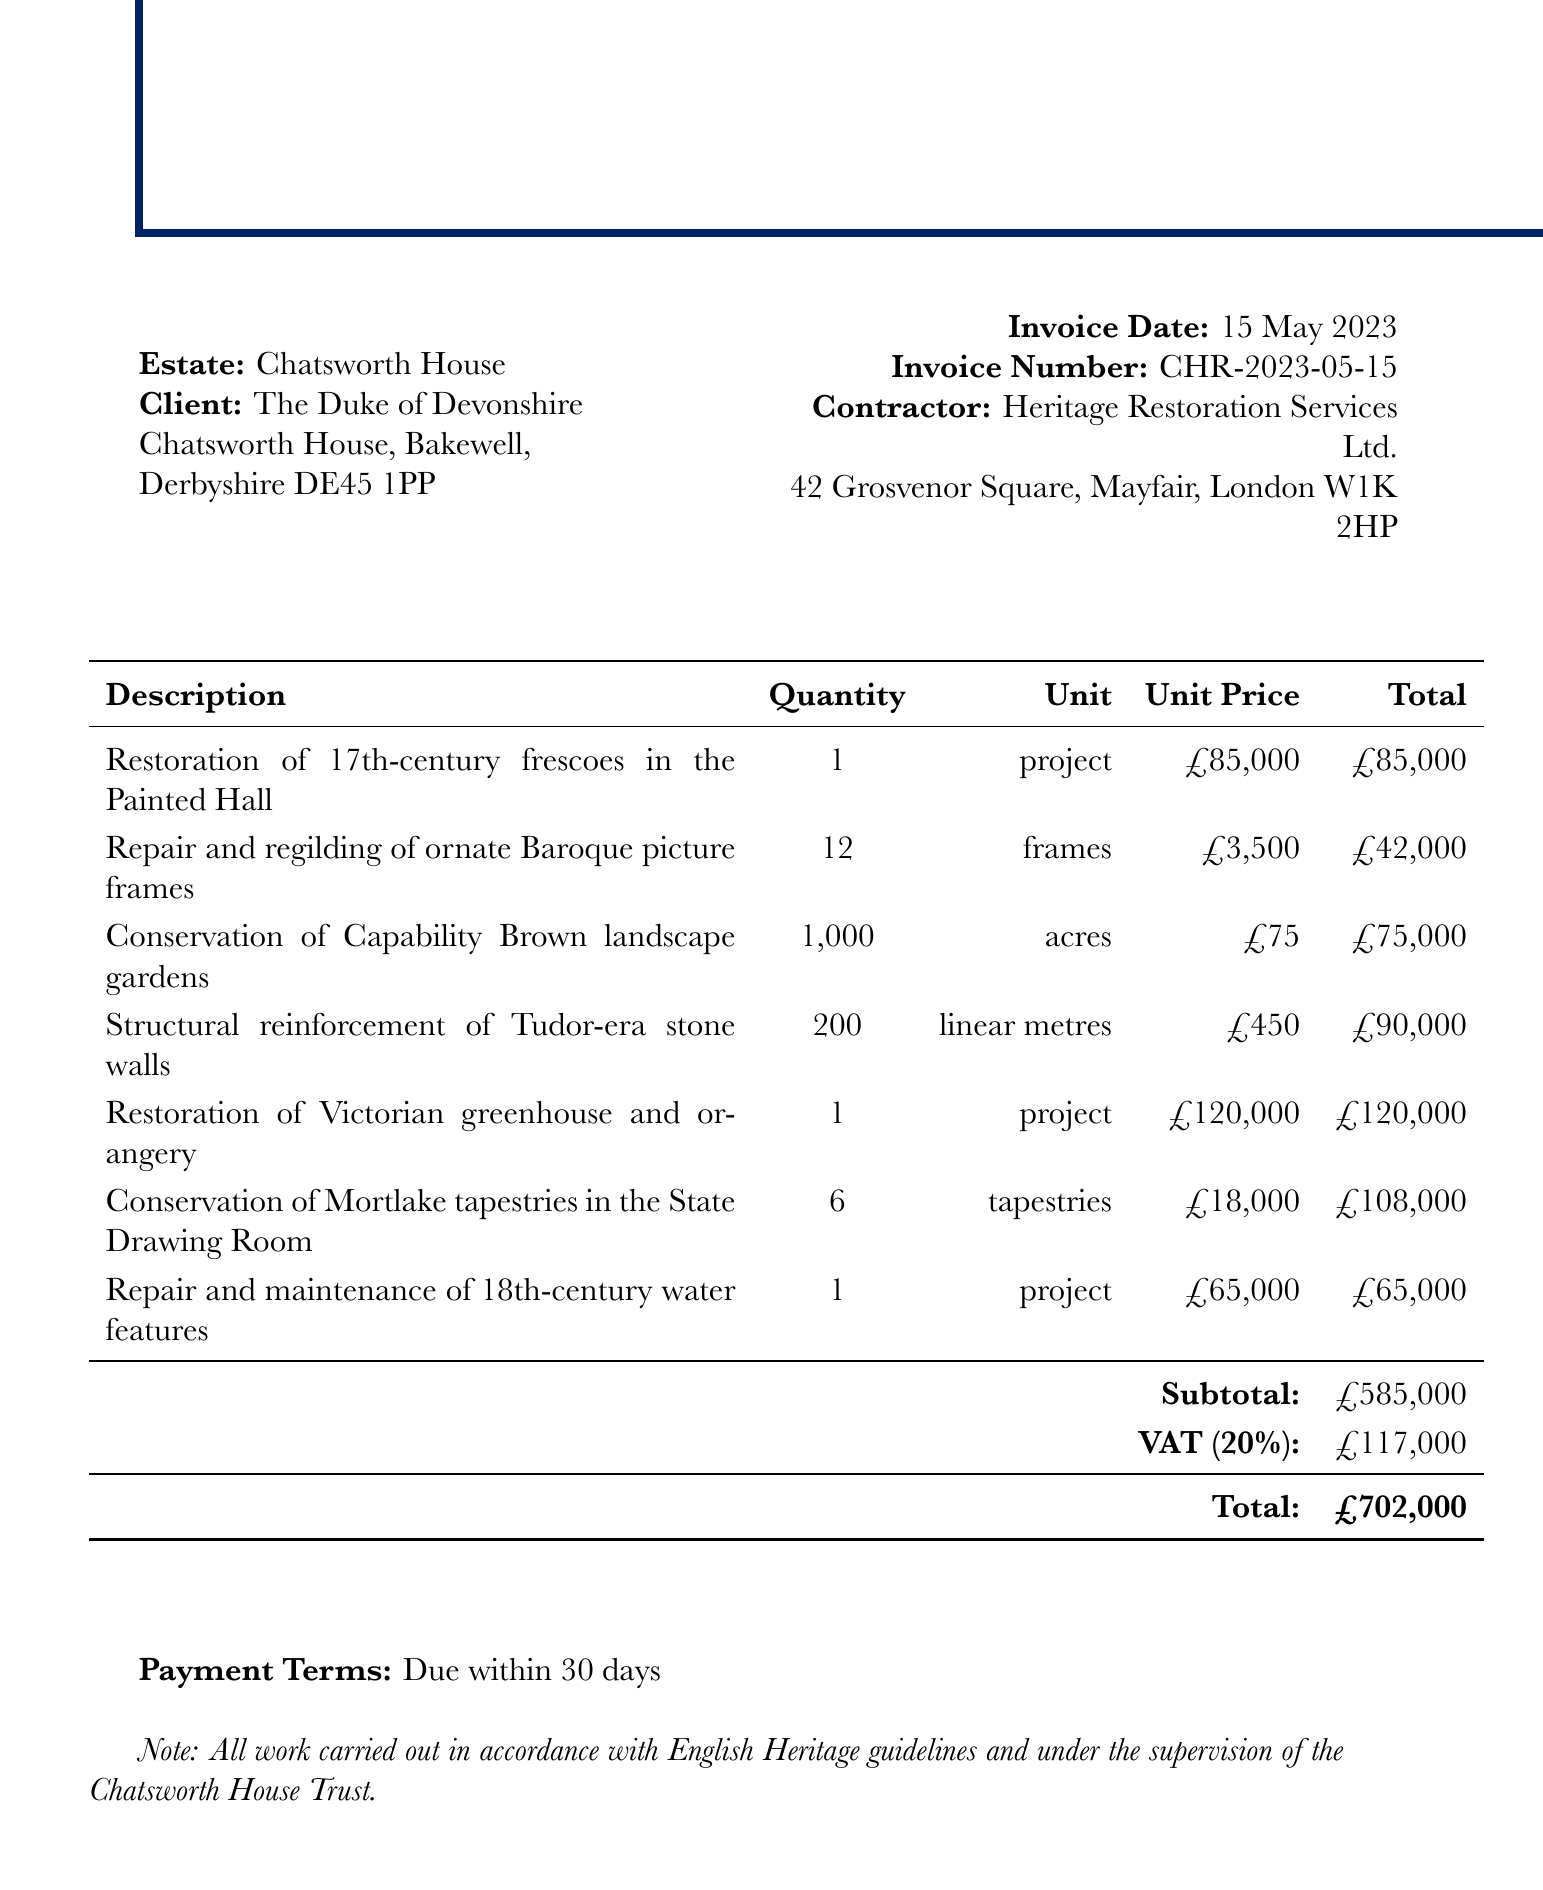What is the estate name? The estate name is clearly mentioned at the top of the document.
Answer: Chatsworth House Who is the client? The client's name and address are listed under the client section of the document.
Answer: The Duke of Devonshire What is the total amount listed on the invoice? The total amount is calculated and presented at the end of the invoice.
Answer: £702,000 How many frames are being restored? The quantity of frames restored is detailed for the specific task in the items section.
Answer: 12 What is the unit price for the restoration of the Victorian greenhouse and orangery? The unit price for the project is noted alongside its description in the invoice.
Answer: £120,000 What is the subtotal before VAT? The subtotal is provided as a clear breakdown before the VAT is added.
Answer: £585,000 What are the payment terms for this invoice? The payment terms are noted towards the end of the document, specifying the due date.
Answer: Due within 30 days Who is the contractor for the restoration services? The contractor's name and address are listed in the header of the document.
Answer: Heritage Restoration Services Ltd How many tapestry conservations are included? The quantity of tapestries being conserved is specified in the description of the services.
Answer: 6 